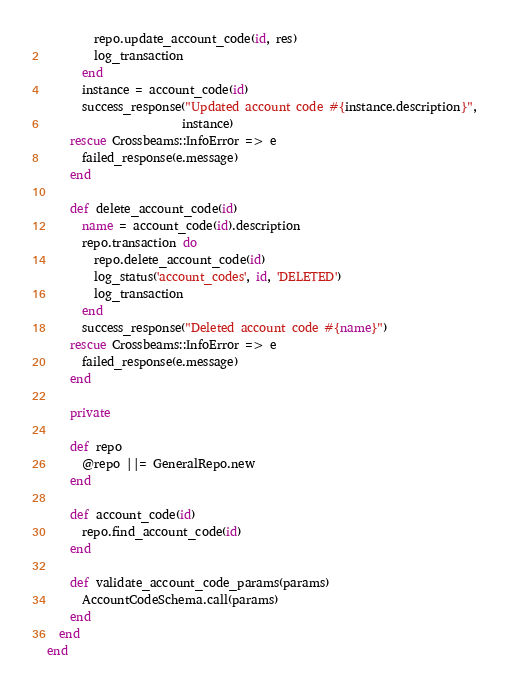Convert code to text. <code><loc_0><loc_0><loc_500><loc_500><_Ruby_>        repo.update_account_code(id, res)
        log_transaction
      end
      instance = account_code(id)
      success_response("Updated account code #{instance.description}",
                       instance)
    rescue Crossbeams::InfoError => e
      failed_response(e.message)
    end

    def delete_account_code(id)
      name = account_code(id).description
      repo.transaction do
        repo.delete_account_code(id)
        log_status('account_codes', id, 'DELETED')
        log_transaction
      end
      success_response("Deleted account code #{name}")
    rescue Crossbeams::InfoError => e
      failed_response(e.message)
    end

    private

    def repo
      @repo ||= GeneralRepo.new
    end

    def account_code(id)
      repo.find_account_code(id)
    end

    def validate_account_code_params(params)
      AccountCodeSchema.call(params)
    end
  end
end
</code> 